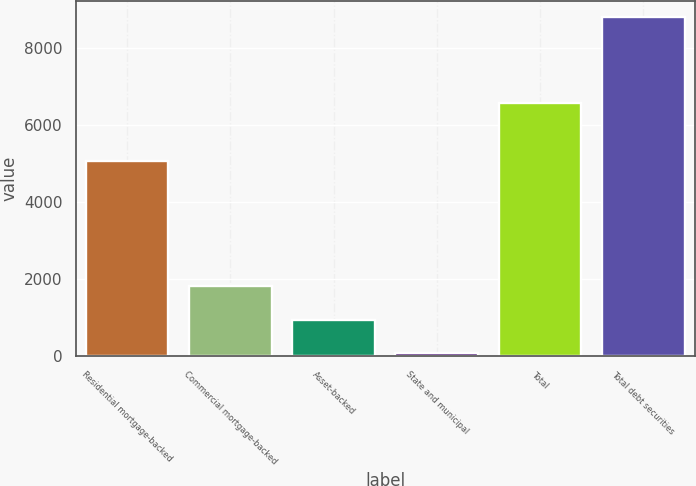<chart> <loc_0><loc_0><loc_500><loc_500><bar_chart><fcel>Residential mortgage-backed<fcel>Commercial mortgage-backed<fcel>Asset-backed<fcel>State and municipal<fcel>Total<fcel>Total debt securities<nl><fcel>5065<fcel>1825.8<fcel>953.9<fcel>82<fcel>6574<fcel>8801<nl></chart> 